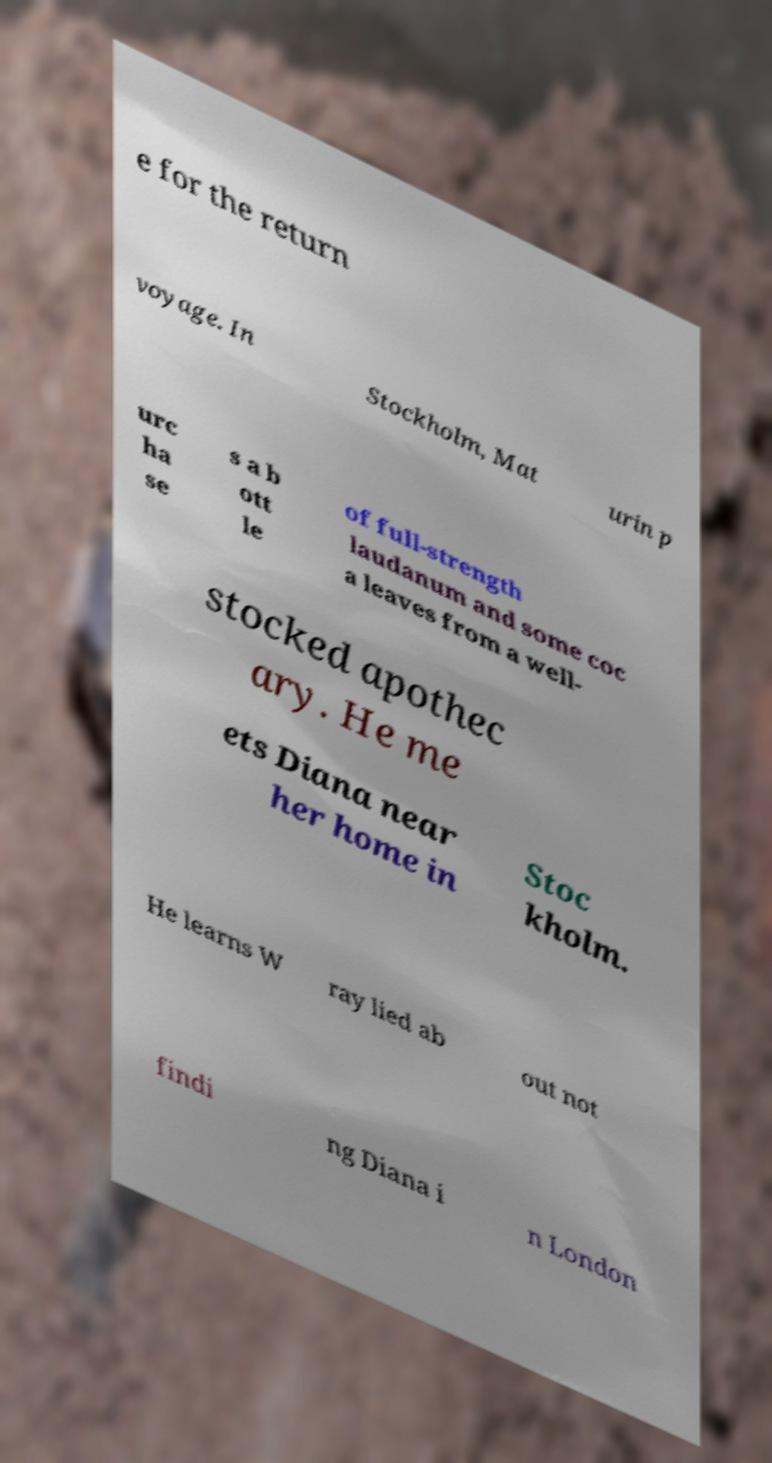I need the written content from this picture converted into text. Can you do that? e for the return voyage. In Stockholm, Mat urin p urc ha se s a b ott le of full-strength laudanum and some coc a leaves from a well- stocked apothec ary. He me ets Diana near her home in Stoc kholm. He learns W ray lied ab out not findi ng Diana i n London 